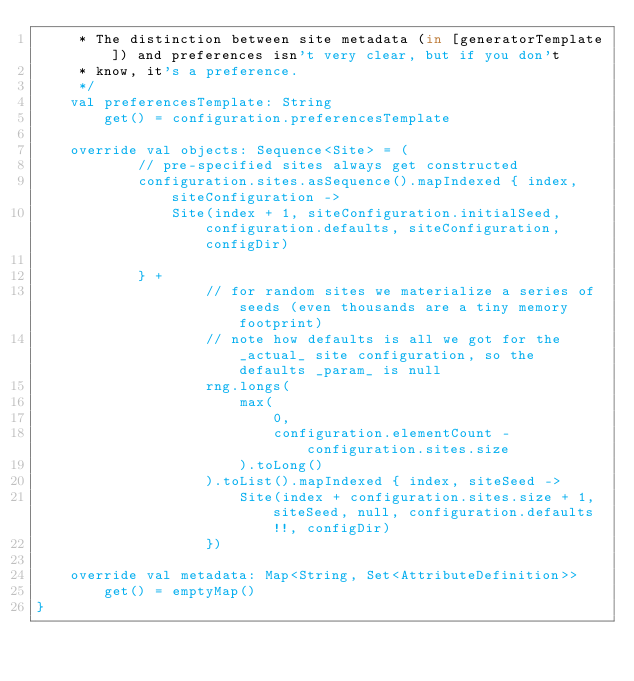Convert code to text. <code><loc_0><loc_0><loc_500><loc_500><_Kotlin_>     * The distinction between site metadata (in [generatorTemplate]) and preferences isn't very clear, but if you don't
     * know, it's a preference.
     */
    val preferencesTemplate: String
        get() = configuration.preferencesTemplate

    override val objects: Sequence<Site> = (
            // pre-specified sites always get constructed
            configuration.sites.asSequence().mapIndexed { index, siteConfiguration ->
                Site(index + 1, siteConfiguration.initialSeed, configuration.defaults, siteConfiguration, configDir)

            } +
                    // for random sites we materialize a series of seeds (even thousands are a tiny memory footprint)
                    // note how defaults is all we got for the _actual_ site configuration, so the defaults _param_ is null
                    rng.longs(
                        max(
                            0,
                            configuration.elementCount - configuration.sites.size
                        ).toLong()
                    ).toList().mapIndexed { index, siteSeed ->
                        Site(index + configuration.sites.size + 1, siteSeed, null, configuration.defaults!!, configDir)
                    })

    override val metadata: Map<String, Set<AttributeDefinition>>
        get() = emptyMap()
}</code> 